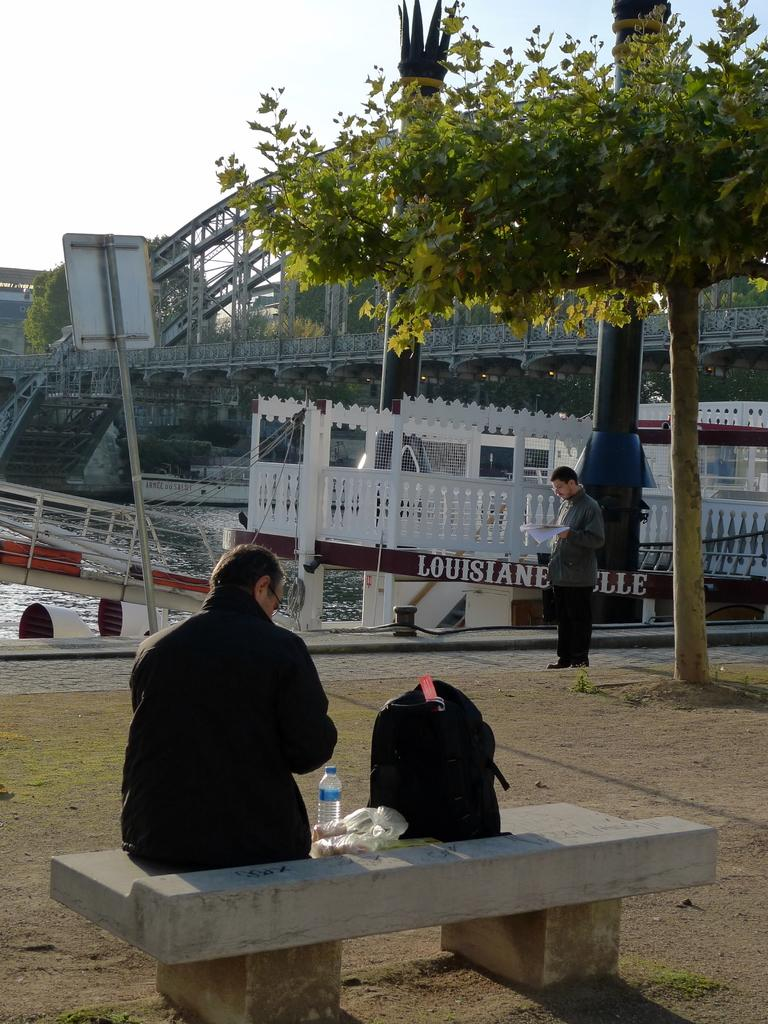What is the man in the image doing? The man is sitting in the image. Where is the man sitting? The man is sitting on a bench. What else is on the bench? There is a bag on the bench. What can be seen in the background of the image? There is a tree in the image. Can you describe the person standing in the image? There is a person standing on a footpath. What type of vegetable is being used to paint the division between the man and the tree in the image? There is no vegetable or paint present in the image, and no division between the man and the tree is depicted. 